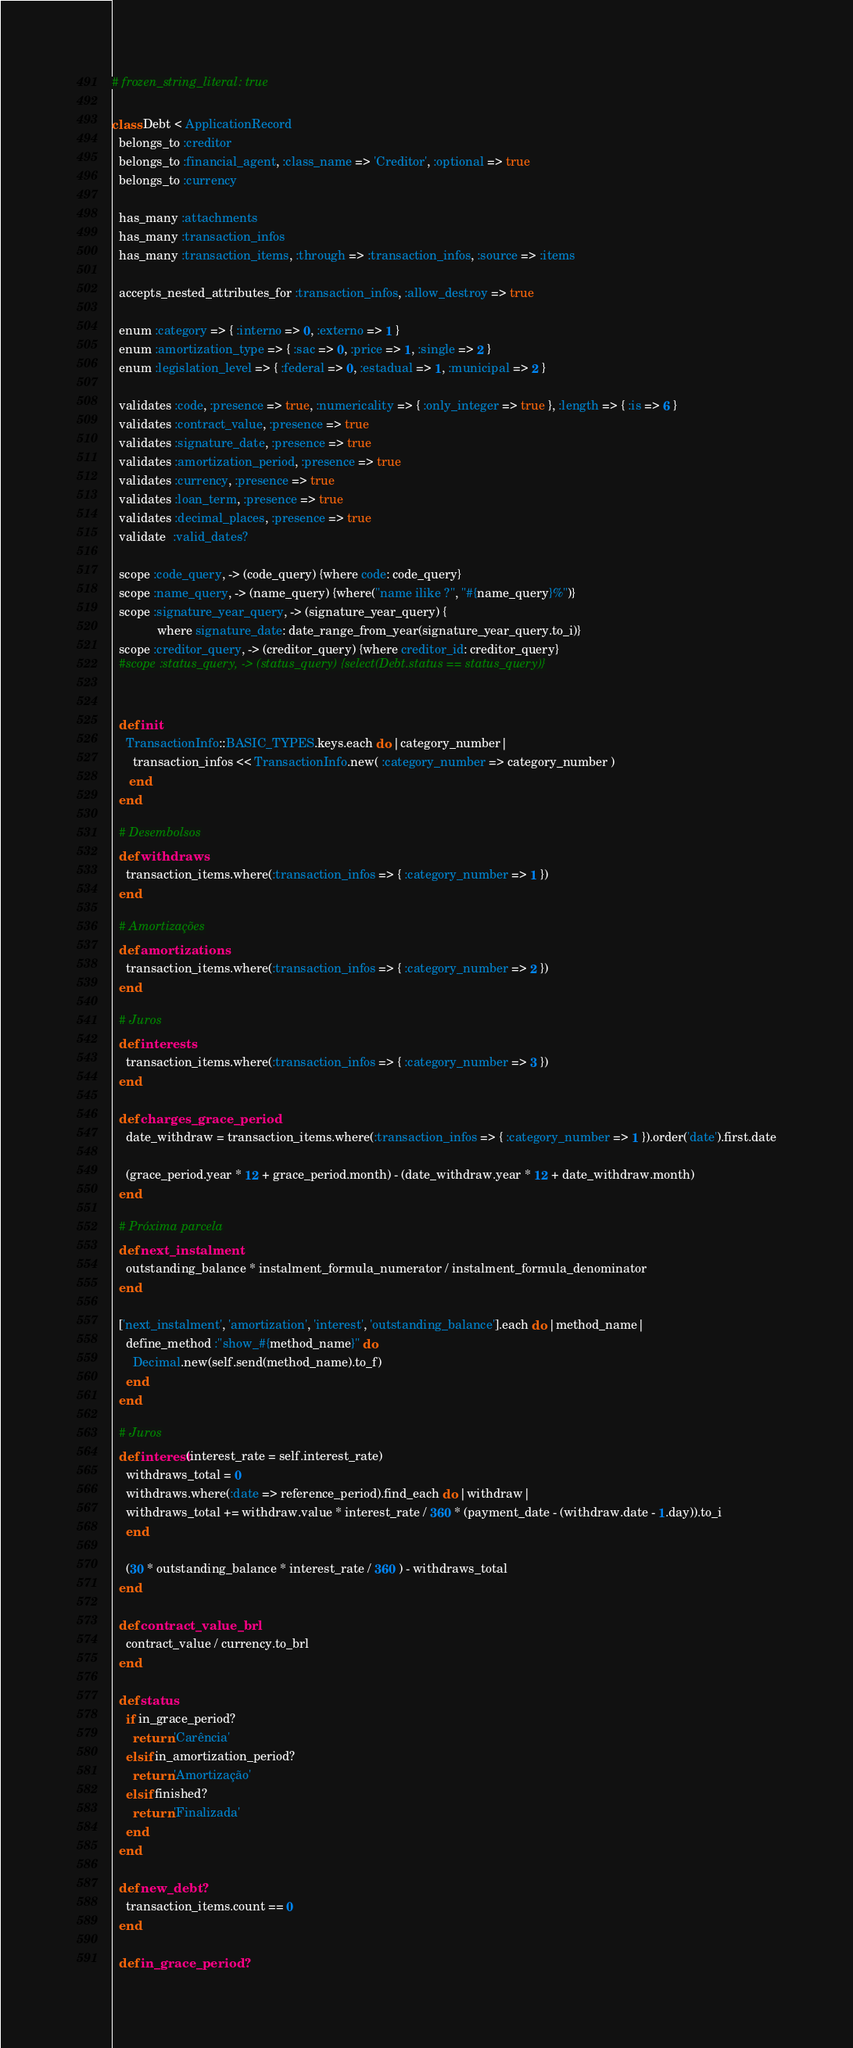Convert code to text. <code><loc_0><loc_0><loc_500><loc_500><_Ruby_># frozen_string_literal: true

class Debt < ApplicationRecord
  belongs_to :creditor
  belongs_to :financial_agent, :class_name => 'Creditor', :optional => true
  belongs_to :currency

  has_many :attachments
  has_many :transaction_infos
  has_many :transaction_items, :through => :transaction_infos, :source => :items
  
  accepts_nested_attributes_for :transaction_infos, :allow_destroy => true
 
  enum :category => { :interno => 0, :externo => 1 }
  enum :amortization_type => { :sac => 0, :price => 1, :single => 2 }
  enum :legislation_level => { :federal => 0, :estadual => 1, :municipal => 2 }
  
  validates :code, :presence => true, :numericality => { :only_integer => true }, :length => { :is => 6 }
  validates :contract_value, :presence => true
  validates :signature_date, :presence => true
  validates :amortization_period, :presence => true
  validates :currency, :presence => true
  validates :loan_term, :presence => true
  validates :decimal_places, :presence => true
  validate  :valid_dates?
 
  scope :code_query, -> (code_query) {where code: code_query}
  scope :name_query, -> (name_query) {where("name ilike ?", "#{name_query}%")}
  scope :signature_year_query, -> (signature_year_query) {
             where signature_date: date_range_from_year(signature_year_query.to_i)}
  scope :creditor_query, -> (creditor_query) {where creditor_id: creditor_query}
  #scope :status_query, -> (status_query) {select(Debt.status == status_query)}

  
  def init
    TransactionInfo::BASIC_TYPES.keys.each do |category_number|
      transaction_infos << TransactionInfo.new( :category_number => category_number )
     end
  end
  
  # Desembolsos
  def withdraws
    transaction_items.where(:transaction_infos => { :category_number => 1 })
  end

  # Amortizações
  def amortizations
    transaction_items.where(:transaction_infos => { :category_number => 2 })
  end 
    
  # Juros
  def interests
    transaction_items.where(:transaction_infos => { :category_number => 3 })
  end

  def charges_grace_period
    date_withdraw = transaction_items.where(:transaction_infos => { :category_number => 1 }).order('date').first.date

    (grace_period.year * 12 + grace_period.month) - (date_withdraw.year * 12 + date_withdraw.month)
  end

  # Próxima parcela
  def next_instalment
    outstanding_balance * instalment_formula_numerator / instalment_formula_denominator
  end	
    
  ['next_instalment', 'amortization', 'interest', 'outstanding_balance'].each do |method_name|
    define_method :"show_#{method_name}" do 
      Decimal.new(self.send(method_name).to_f)
    end
  end

  # Juros
  def interest(interest_rate = self.interest_rate)
    withdraws_total = 0
    withdraws.where(:date => reference_period).find_each do |withdraw|
    withdraws_total += withdraw.value * interest_rate / 360 * (payment_date - (withdraw.date - 1.day)).to_i
    end

    (30 * outstanding_balance * interest_rate / 360 ) - withdraws_total
  end

  def contract_value_brl
    contract_value / currency.to_brl	
  end

  def status
    if in_grace_period?
      return 'Carência'
    elsif in_amortization_period?
      return 'Amortização'
    elsif finished?
      return 'Finalizada'
    end
  end

  def new_debt?
    transaction_items.count == 0
  end

  def in_grace_period?</code> 